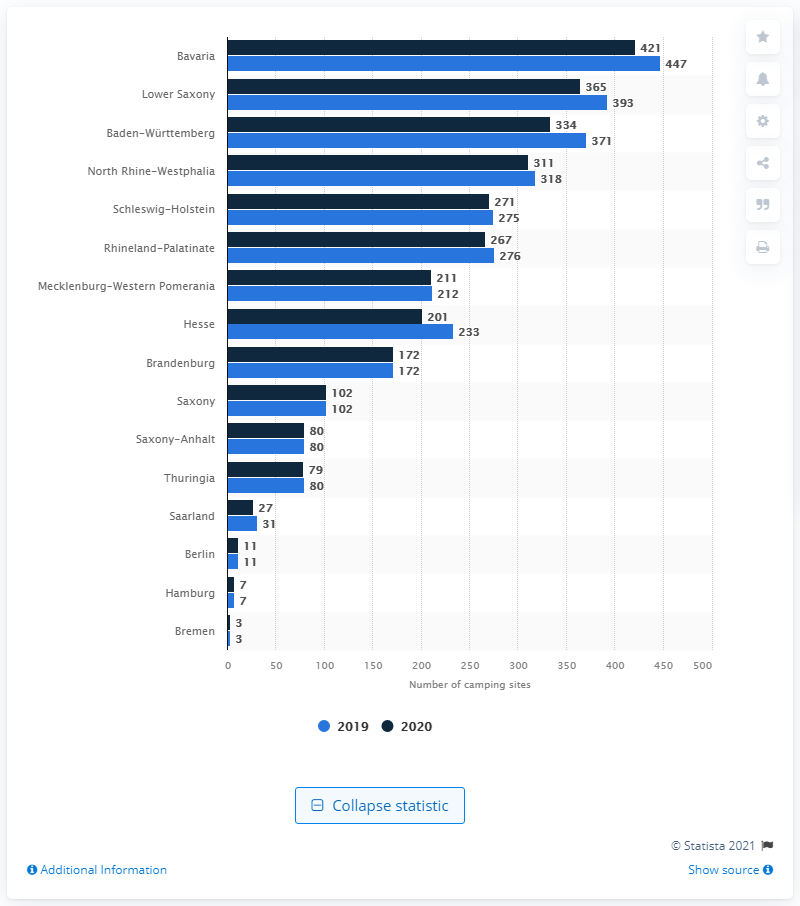Identify some key points in this picture. Bavaria had the highest number of camping sites in Germany in 2020. 